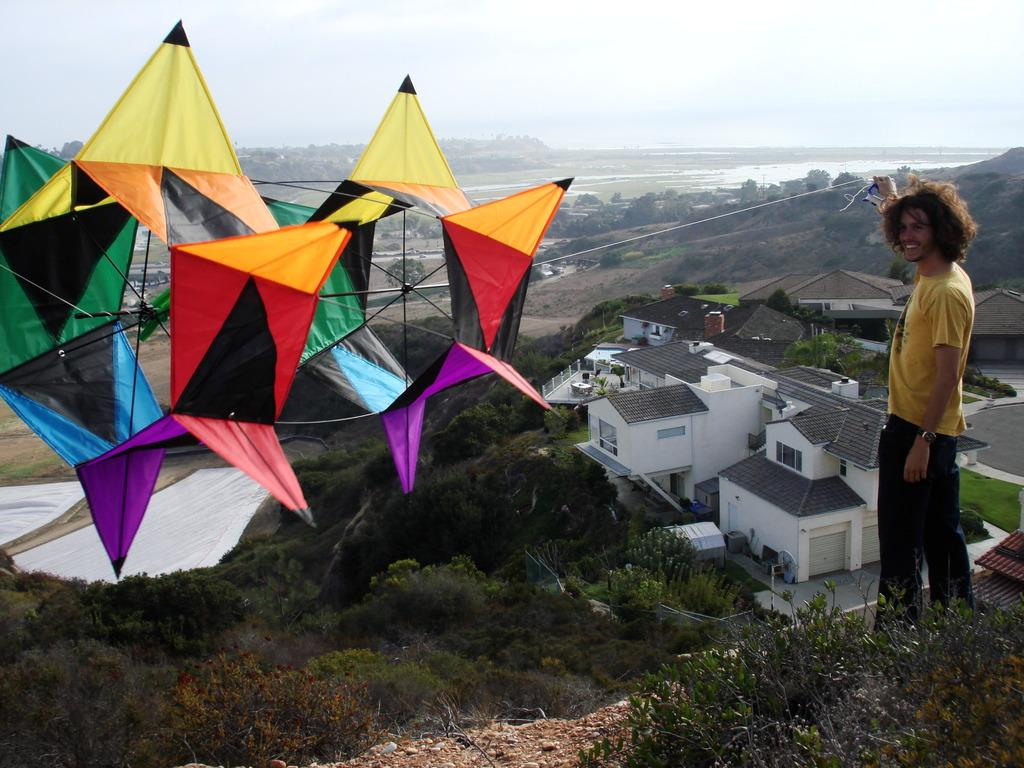Who is present in the image? There is a man in the image. What is the man wearing? The man is wearing a yellow t-shirt. What is the man holding in the image? The man is holding a rope. What is the rope attached to? The rope is attached to a kite. What can be seen in the background of the image? There are houses, trees, and the sky visible in the background of the image. What type of toothpaste is the man using to clean the kite in the image? There is no toothpaste present in the image, and the man is not cleaning the kite. 